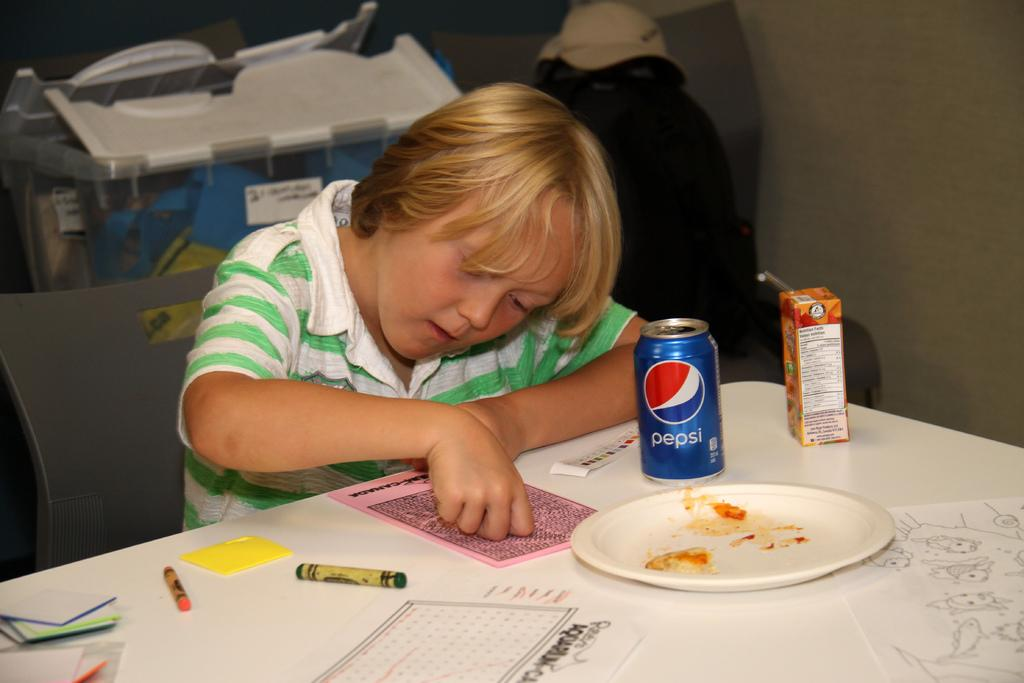<image>
Create a compact narrative representing the image presented. A child writes with a crayon next to an empty plate, a can of pepsi, and a juice box. 